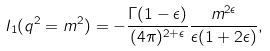Convert formula to latex. <formula><loc_0><loc_0><loc_500><loc_500>I _ { 1 } ( q ^ { 2 } = m ^ { 2 } ) = - \frac { \Gamma ( 1 - \epsilon ) } { ( 4 \pi ) ^ { 2 + \epsilon } } \frac { m ^ { 2 \epsilon } } { \epsilon ( 1 + 2 \epsilon ) } ,</formula> 